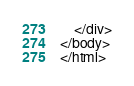Convert code to text. <code><loc_0><loc_0><loc_500><loc_500><_HTML_>    </div>
</body>
</html></code> 